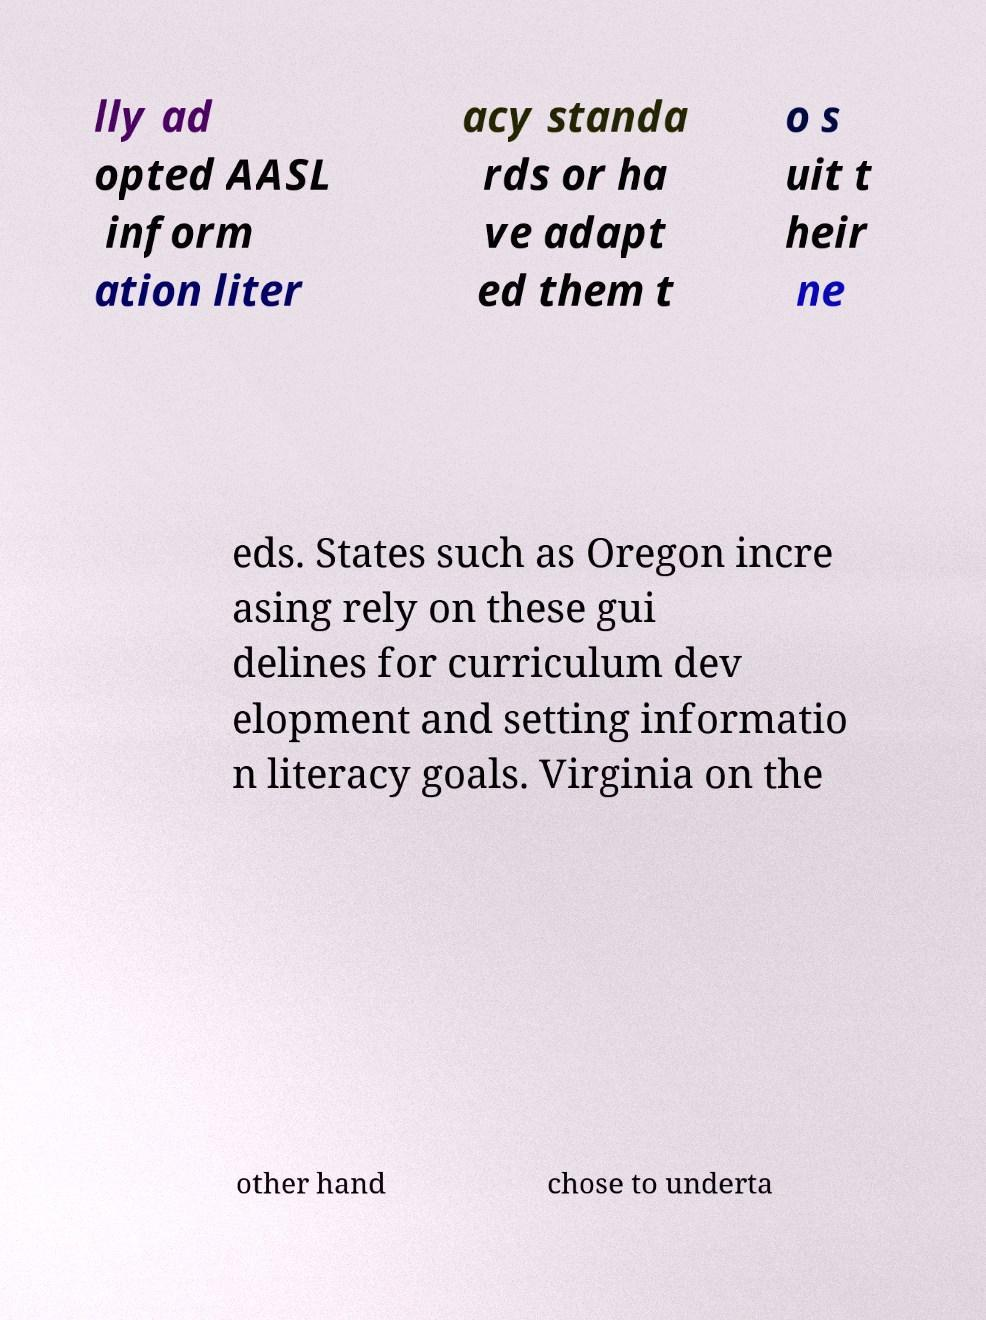What messages or text are displayed in this image? I need them in a readable, typed format. lly ad opted AASL inform ation liter acy standa rds or ha ve adapt ed them t o s uit t heir ne eds. States such as Oregon incre asing rely on these gui delines for curriculum dev elopment and setting informatio n literacy goals. Virginia on the other hand chose to underta 